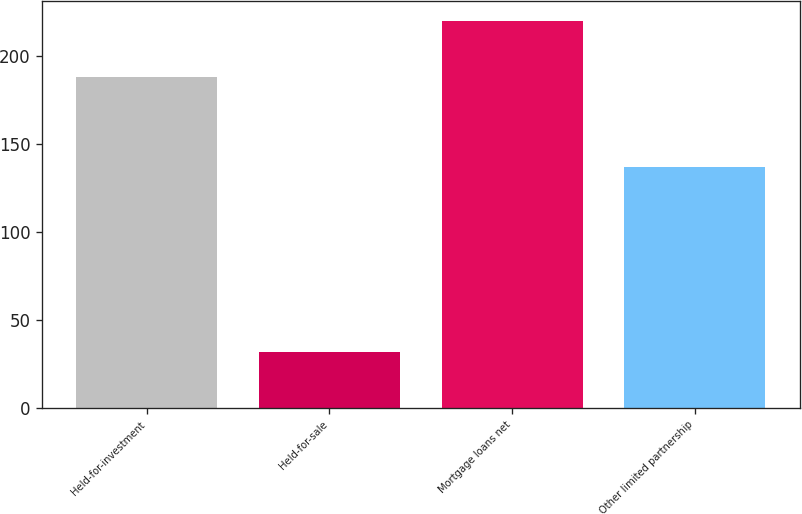Convert chart to OTSL. <chart><loc_0><loc_0><loc_500><loc_500><bar_chart><fcel>Held-for-investment<fcel>Held-for-sale<fcel>Mortgage loans net<fcel>Other limited partnership<nl><fcel>188<fcel>32<fcel>220<fcel>137<nl></chart> 